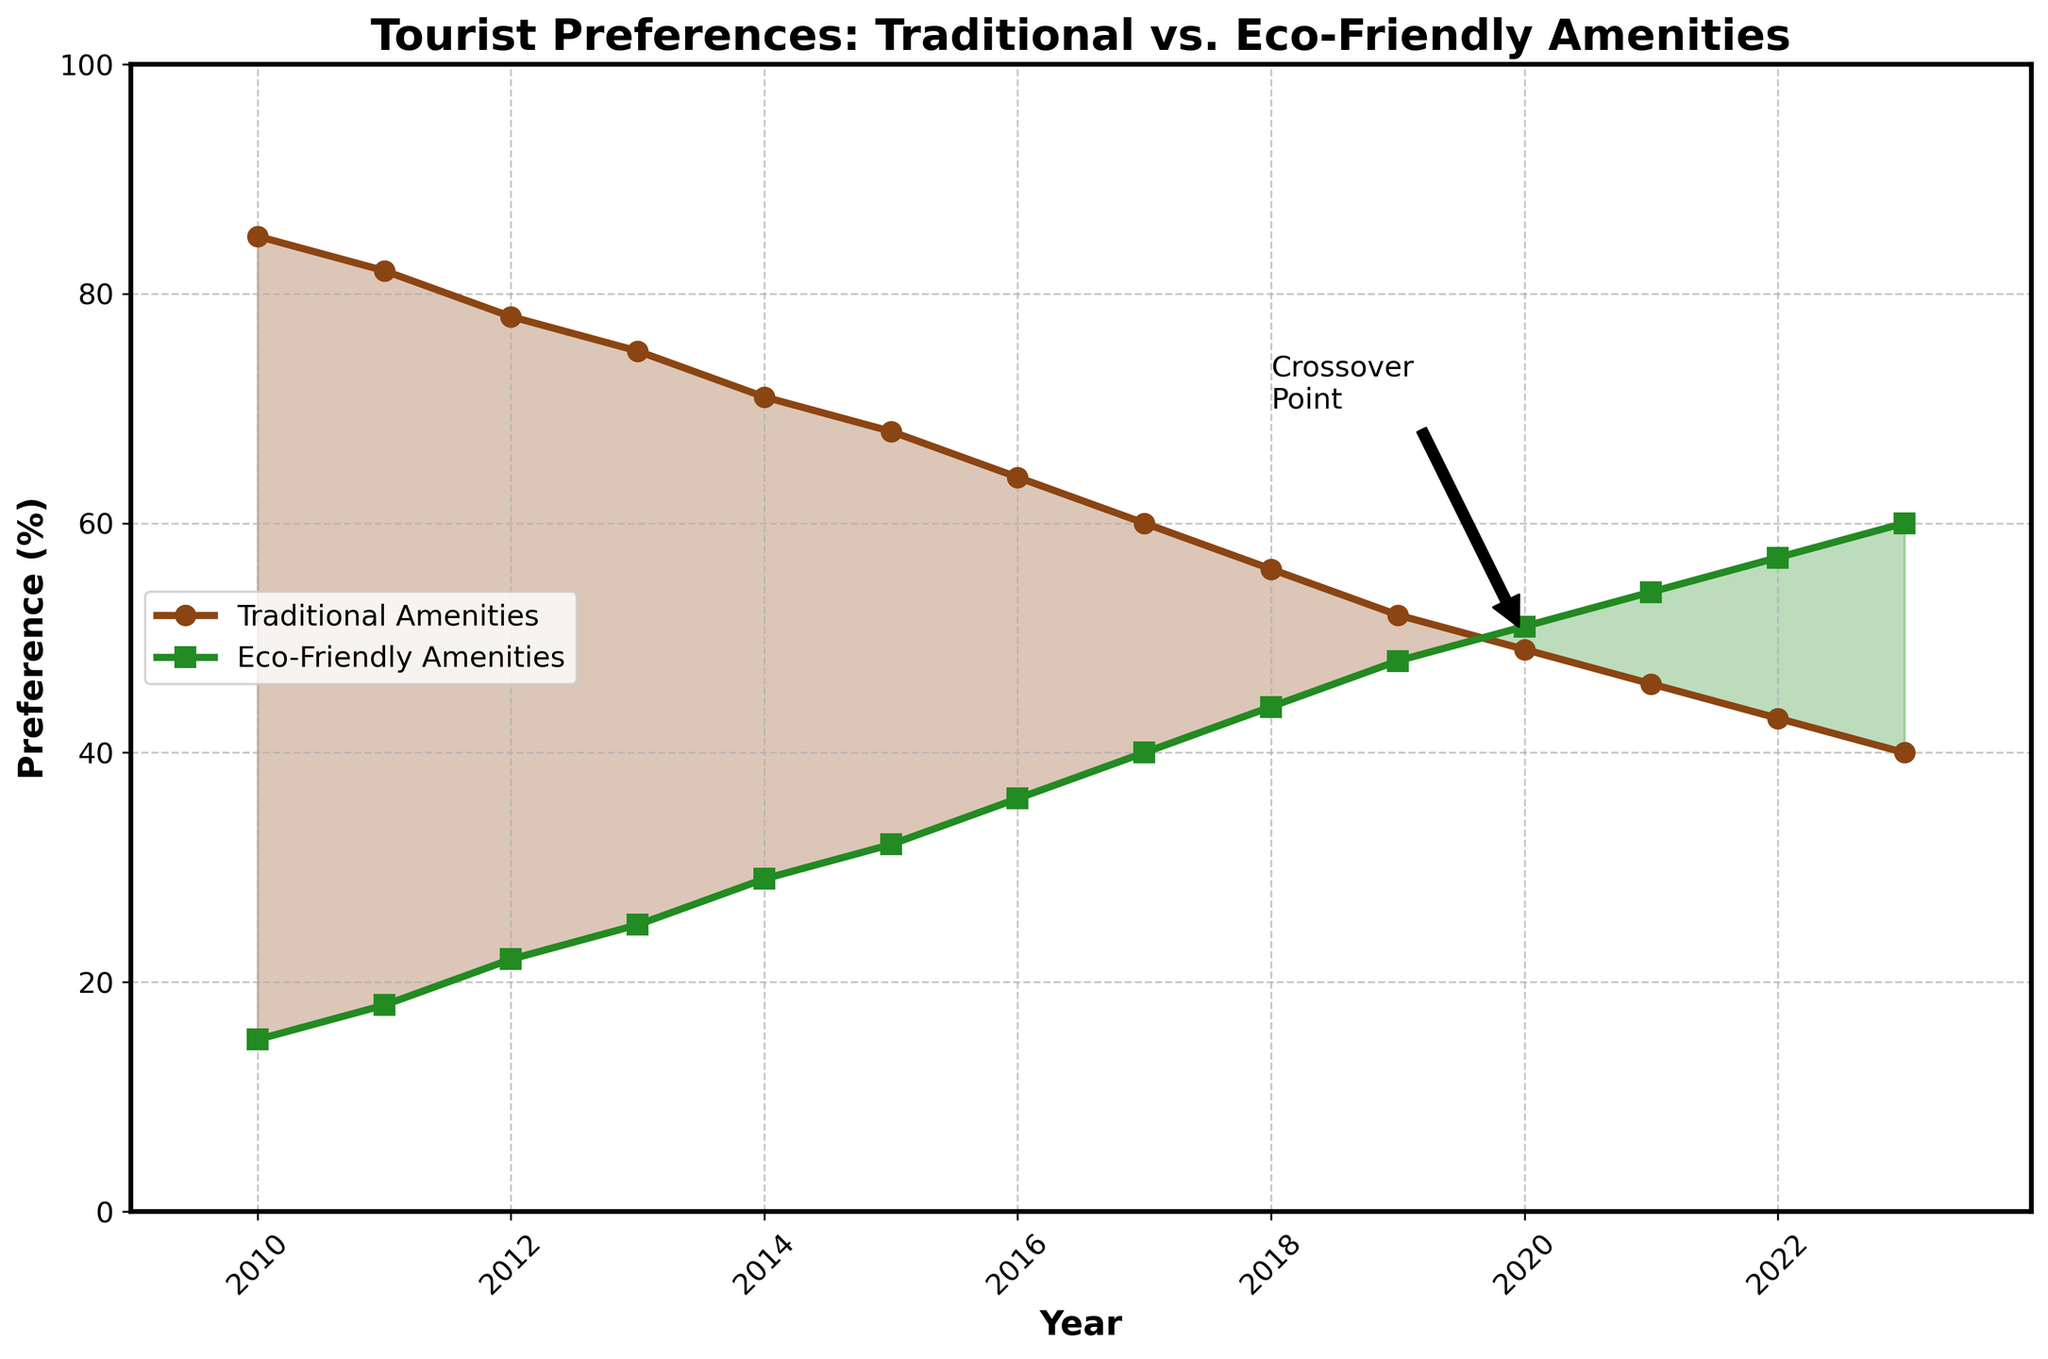What's the general trend for tourist preferences for traditional amenities from 2010 to 2023? The tourist preferences for traditional amenities show a clear downward trend from 85% in 2010 to 40% in 2023.
Answer: Downward In which year did the preference for eco-friendly amenities first exceed 50%? In the year 2020, the preference for eco-friendly amenities first exceeded 50%, with a value of 51%.
Answer: 2020 How much has the preference for traditional amenities decreased from 2010 to 2023? The preference for traditional amenities decreased from 85% in 2010 to 40% in 2023. The decrease is 85 - 40 = 45%.
Answer: 45% What is the crossover year where the preference for eco-friendly amenities surpassed traditional amenities? The crossover occurred around 2020, as indicated by the annotation marking the crossover point.
Answer: 2020 What's the average preference for traditional amenities over the entire period? The values for traditional amenities are: 85, 82, 78, 75, 71, 68, 64, 60, 56, 52, 49, 46, 43, and 40. Sum them up: 85 + 82 + 78 + 75 + 71 + 68 + 64 + 60 + 56 + 52 + 49 + 46 + 43 + 40 = 869. The average is 869 / 14 = 62.07%
Answer: 62.07% Between which years is the increase in preference for eco-friendly amenities the largest? The largest year-to-year increase for eco-friendly amenities is between 2018 and 2019, where the preference increased from 44% to 48%, which is an increase of 4%.
Answer: 2018-2019 During which years did the preference for traditional amenities drop below 50%? The preference for traditional amenities dropped below 50% starting in the year 2020, where it reached 49%.
Answer: 2020 onward What is the gap between preferences for traditional and eco-friendly amenities in 2015? In 2015, the preference for traditional amenities was 68%, and for eco-friendly amenities, it was 32%. The gap is 68 - 32 = 36%.
Answer: 36% Which amenities had a higher preference in 2017, and by how much? In 2017, traditional amenities had a higher preference at 60%, compared to 40% for eco-friendly amenities. The difference is 60 - 40 = 20%.
Answer: Traditional, 20% What visual cue indicates the crossover point in the chart? The crossover point is visually indicated by an annotation labeled "Crossover Point" with an arrow pointing to the year 2020 on the chart.
Answer: Annotation and arrow 